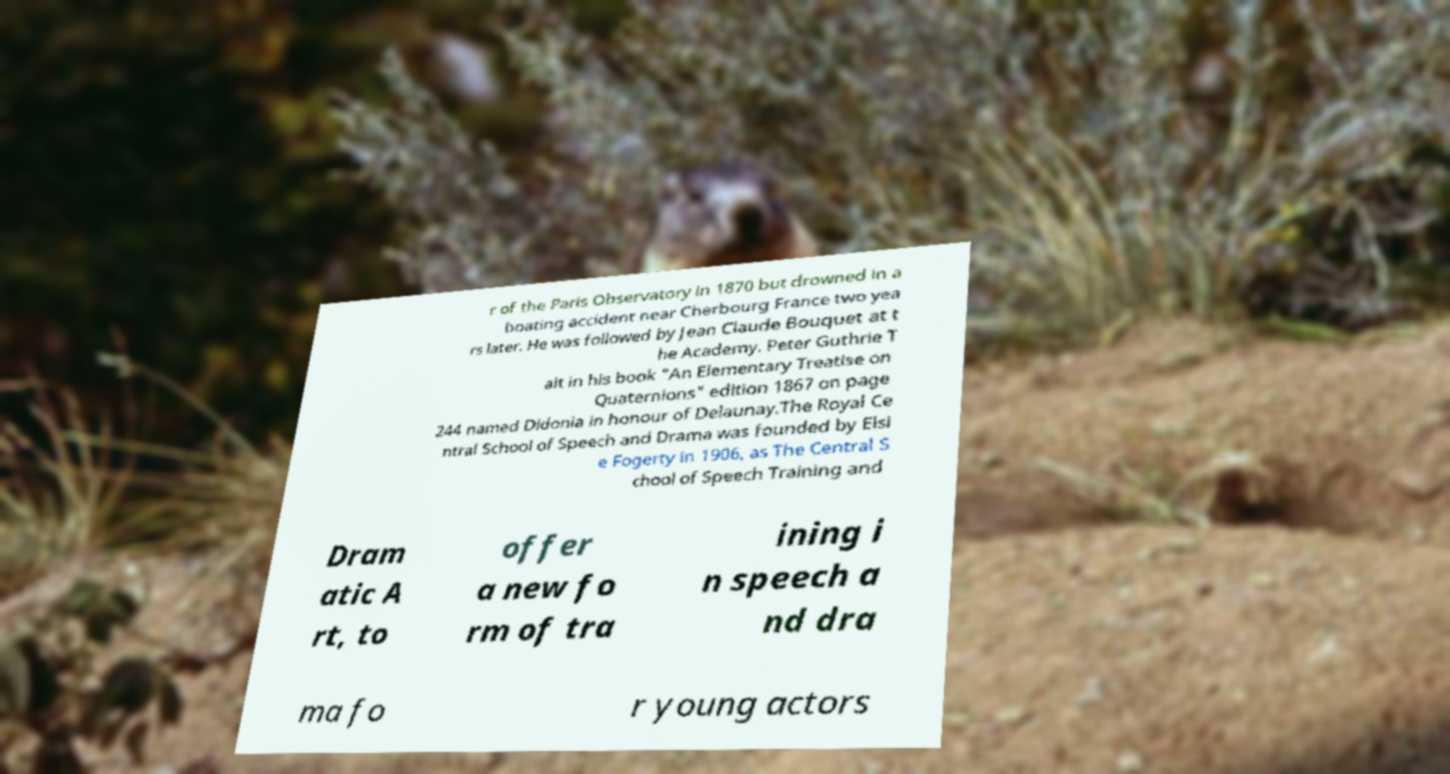What messages or text are displayed in this image? I need them in a readable, typed format. r of the Paris Observatory in 1870 but drowned in a boating accident near Cherbourg France two yea rs later. He was followed by Jean Claude Bouquet at t he Academy. Peter Guthrie T ait in his book "An Elementary Treatise on Quaternions" edition 1867 on page 244 named Didonia in honour of Delaunay.The Royal Ce ntral School of Speech and Drama was founded by Elsi e Fogerty in 1906, as The Central S chool of Speech Training and Dram atic A rt, to offer a new fo rm of tra ining i n speech a nd dra ma fo r young actors 